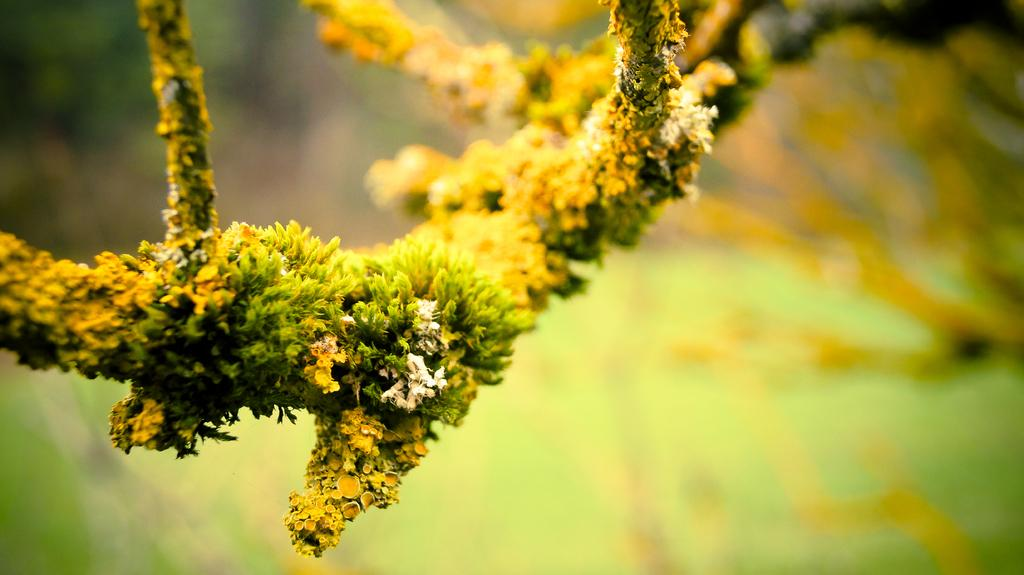What type of tree branch is in the picture? There is a branch of a larch tree in the picture. How is the background of the branch depicted? The background of the branch is blurred. How many chairs are placed around the larch tree branch in the image? There are no chairs present in the image; it only features a branch of a larch tree with a blurred background. 